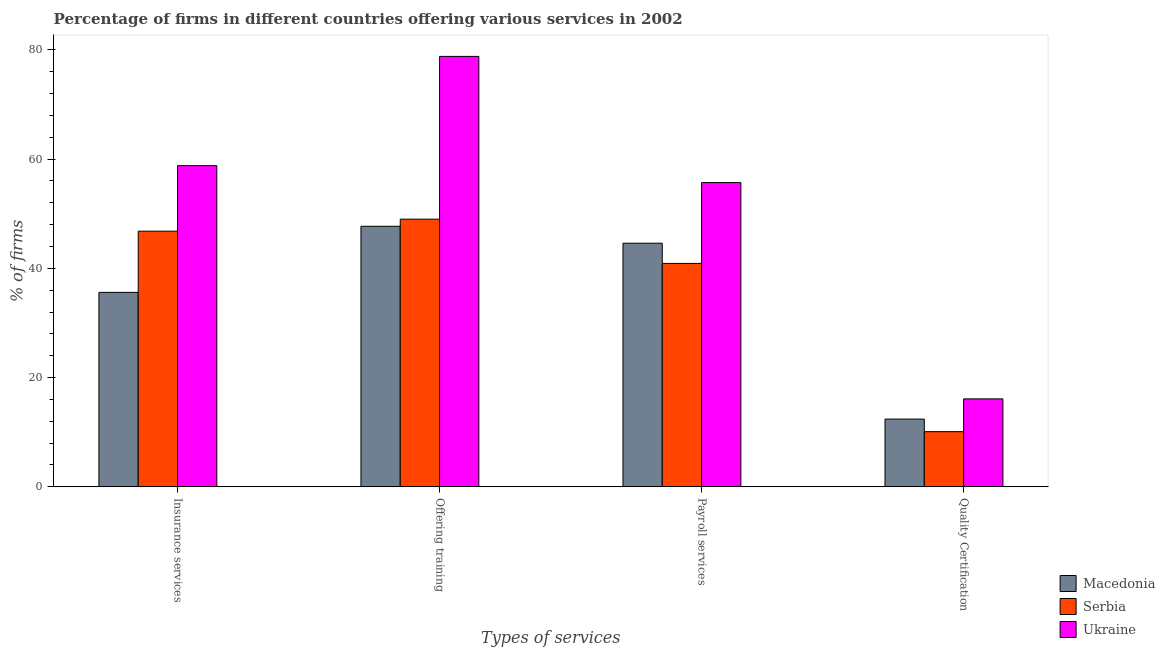How many different coloured bars are there?
Your response must be concise. 3. How many groups of bars are there?
Keep it short and to the point. 4. What is the label of the 4th group of bars from the left?
Your response must be concise. Quality Certification. What is the percentage of firms offering training in Ukraine?
Offer a terse response. 78.8. Across all countries, what is the maximum percentage of firms offering quality certification?
Provide a short and direct response. 16.1. Across all countries, what is the minimum percentage of firms offering quality certification?
Keep it short and to the point. 10.1. In which country was the percentage of firms offering quality certification maximum?
Your response must be concise. Ukraine. In which country was the percentage of firms offering payroll services minimum?
Keep it short and to the point. Serbia. What is the total percentage of firms offering training in the graph?
Provide a succinct answer. 175.5. What is the difference between the percentage of firms offering payroll services in Macedonia and that in Ukraine?
Your answer should be compact. -11.1. What is the average percentage of firms offering training per country?
Give a very brief answer. 58.5. What is the difference between the percentage of firms offering payroll services and percentage of firms offering insurance services in Serbia?
Your response must be concise. -5.9. What is the ratio of the percentage of firms offering training in Ukraine to that in Macedonia?
Give a very brief answer. 1.65. Is the difference between the percentage of firms offering training in Serbia and Ukraine greater than the difference between the percentage of firms offering quality certification in Serbia and Ukraine?
Your answer should be compact. No. What is the difference between the highest and the second highest percentage of firms offering payroll services?
Give a very brief answer. 11.1. What is the difference between the highest and the lowest percentage of firms offering quality certification?
Provide a short and direct response. 6. Is it the case that in every country, the sum of the percentage of firms offering quality certification and percentage of firms offering payroll services is greater than the sum of percentage of firms offering insurance services and percentage of firms offering training?
Your answer should be compact. Yes. What does the 1st bar from the left in Quality Certification represents?
Provide a succinct answer. Macedonia. What does the 2nd bar from the right in Offering training represents?
Ensure brevity in your answer.  Serbia. Is it the case that in every country, the sum of the percentage of firms offering insurance services and percentage of firms offering training is greater than the percentage of firms offering payroll services?
Provide a short and direct response. Yes. How many bars are there?
Provide a short and direct response. 12. Are the values on the major ticks of Y-axis written in scientific E-notation?
Provide a succinct answer. No. Does the graph contain any zero values?
Give a very brief answer. No. What is the title of the graph?
Ensure brevity in your answer.  Percentage of firms in different countries offering various services in 2002. What is the label or title of the X-axis?
Provide a short and direct response. Types of services. What is the label or title of the Y-axis?
Offer a terse response. % of firms. What is the % of firms in Macedonia in Insurance services?
Offer a terse response. 35.6. What is the % of firms of Serbia in Insurance services?
Your response must be concise. 46.8. What is the % of firms of Ukraine in Insurance services?
Keep it short and to the point. 58.8. What is the % of firms in Macedonia in Offering training?
Your response must be concise. 47.7. What is the % of firms in Serbia in Offering training?
Provide a succinct answer. 49. What is the % of firms of Ukraine in Offering training?
Make the answer very short. 78.8. What is the % of firms of Macedonia in Payroll services?
Your response must be concise. 44.6. What is the % of firms of Serbia in Payroll services?
Make the answer very short. 40.9. What is the % of firms of Ukraine in Payroll services?
Provide a short and direct response. 55.7. What is the % of firms in Serbia in Quality Certification?
Provide a succinct answer. 10.1. Across all Types of services, what is the maximum % of firms in Macedonia?
Your answer should be compact. 47.7. Across all Types of services, what is the maximum % of firms in Ukraine?
Your answer should be very brief. 78.8. Across all Types of services, what is the minimum % of firms of Serbia?
Make the answer very short. 10.1. Across all Types of services, what is the minimum % of firms in Ukraine?
Offer a very short reply. 16.1. What is the total % of firms in Macedonia in the graph?
Ensure brevity in your answer.  140.3. What is the total % of firms in Serbia in the graph?
Provide a short and direct response. 146.8. What is the total % of firms of Ukraine in the graph?
Provide a short and direct response. 209.4. What is the difference between the % of firms of Ukraine in Insurance services and that in Offering training?
Make the answer very short. -20. What is the difference between the % of firms of Ukraine in Insurance services and that in Payroll services?
Offer a terse response. 3.1. What is the difference between the % of firms of Macedonia in Insurance services and that in Quality Certification?
Provide a succinct answer. 23.2. What is the difference between the % of firms in Serbia in Insurance services and that in Quality Certification?
Your answer should be compact. 36.7. What is the difference between the % of firms of Ukraine in Insurance services and that in Quality Certification?
Your answer should be very brief. 42.7. What is the difference between the % of firms of Serbia in Offering training and that in Payroll services?
Provide a short and direct response. 8.1. What is the difference between the % of firms in Ukraine in Offering training and that in Payroll services?
Provide a succinct answer. 23.1. What is the difference between the % of firms in Macedonia in Offering training and that in Quality Certification?
Provide a succinct answer. 35.3. What is the difference between the % of firms in Serbia in Offering training and that in Quality Certification?
Keep it short and to the point. 38.9. What is the difference between the % of firms in Ukraine in Offering training and that in Quality Certification?
Keep it short and to the point. 62.7. What is the difference between the % of firms of Macedonia in Payroll services and that in Quality Certification?
Ensure brevity in your answer.  32.2. What is the difference between the % of firms in Serbia in Payroll services and that in Quality Certification?
Give a very brief answer. 30.8. What is the difference between the % of firms of Ukraine in Payroll services and that in Quality Certification?
Keep it short and to the point. 39.6. What is the difference between the % of firms in Macedonia in Insurance services and the % of firms in Ukraine in Offering training?
Your answer should be compact. -43.2. What is the difference between the % of firms in Serbia in Insurance services and the % of firms in Ukraine in Offering training?
Offer a terse response. -32. What is the difference between the % of firms of Macedonia in Insurance services and the % of firms of Ukraine in Payroll services?
Keep it short and to the point. -20.1. What is the difference between the % of firms of Macedonia in Insurance services and the % of firms of Serbia in Quality Certification?
Your response must be concise. 25.5. What is the difference between the % of firms of Macedonia in Insurance services and the % of firms of Ukraine in Quality Certification?
Keep it short and to the point. 19.5. What is the difference between the % of firms in Serbia in Insurance services and the % of firms in Ukraine in Quality Certification?
Make the answer very short. 30.7. What is the difference between the % of firms in Macedonia in Offering training and the % of firms in Serbia in Payroll services?
Provide a succinct answer. 6.8. What is the difference between the % of firms in Serbia in Offering training and the % of firms in Ukraine in Payroll services?
Offer a very short reply. -6.7. What is the difference between the % of firms of Macedonia in Offering training and the % of firms of Serbia in Quality Certification?
Provide a short and direct response. 37.6. What is the difference between the % of firms in Macedonia in Offering training and the % of firms in Ukraine in Quality Certification?
Give a very brief answer. 31.6. What is the difference between the % of firms in Serbia in Offering training and the % of firms in Ukraine in Quality Certification?
Make the answer very short. 32.9. What is the difference between the % of firms of Macedonia in Payroll services and the % of firms of Serbia in Quality Certification?
Offer a terse response. 34.5. What is the difference between the % of firms of Macedonia in Payroll services and the % of firms of Ukraine in Quality Certification?
Provide a succinct answer. 28.5. What is the difference between the % of firms in Serbia in Payroll services and the % of firms in Ukraine in Quality Certification?
Provide a short and direct response. 24.8. What is the average % of firms in Macedonia per Types of services?
Provide a succinct answer. 35.08. What is the average % of firms in Serbia per Types of services?
Provide a short and direct response. 36.7. What is the average % of firms in Ukraine per Types of services?
Your answer should be very brief. 52.35. What is the difference between the % of firms in Macedonia and % of firms in Serbia in Insurance services?
Offer a very short reply. -11.2. What is the difference between the % of firms in Macedonia and % of firms in Ukraine in Insurance services?
Offer a very short reply. -23.2. What is the difference between the % of firms of Serbia and % of firms of Ukraine in Insurance services?
Offer a very short reply. -12. What is the difference between the % of firms in Macedonia and % of firms in Ukraine in Offering training?
Make the answer very short. -31.1. What is the difference between the % of firms of Serbia and % of firms of Ukraine in Offering training?
Your response must be concise. -29.8. What is the difference between the % of firms in Serbia and % of firms in Ukraine in Payroll services?
Keep it short and to the point. -14.8. What is the difference between the % of firms in Macedonia and % of firms in Serbia in Quality Certification?
Provide a succinct answer. 2.3. What is the difference between the % of firms in Macedonia and % of firms in Ukraine in Quality Certification?
Provide a succinct answer. -3.7. What is the difference between the % of firms in Serbia and % of firms in Ukraine in Quality Certification?
Ensure brevity in your answer.  -6. What is the ratio of the % of firms in Macedonia in Insurance services to that in Offering training?
Ensure brevity in your answer.  0.75. What is the ratio of the % of firms in Serbia in Insurance services to that in Offering training?
Your response must be concise. 0.96. What is the ratio of the % of firms of Ukraine in Insurance services to that in Offering training?
Keep it short and to the point. 0.75. What is the ratio of the % of firms of Macedonia in Insurance services to that in Payroll services?
Offer a terse response. 0.8. What is the ratio of the % of firms of Serbia in Insurance services to that in Payroll services?
Ensure brevity in your answer.  1.14. What is the ratio of the % of firms of Ukraine in Insurance services to that in Payroll services?
Ensure brevity in your answer.  1.06. What is the ratio of the % of firms in Macedonia in Insurance services to that in Quality Certification?
Your answer should be compact. 2.87. What is the ratio of the % of firms of Serbia in Insurance services to that in Quality Certification?
Make the answer very short. 4.63. What is the ratio of the % of firms in Ukraine in Insurance services to that in Quality Certification?
Make the answer very short. 3.65. What is the ratio of the % of firms in Macedonia in Offering training to that in Payroll services?
Offer a terse response. 1.07. What is the ratio of the % of firms in Serbia in Offering training to that in Payroll services?
Your response must be concise. 1.2. What is the ratio of the % of firms in Ukraine in Offering training to that in Payroll services?
Ensure brevity in your answer.  1.41. What is the ratio of the % of firms in Macedonia in Offering training to that in Quality Certification?
Your response must be concise. 3.85. What is the ratio of the % of firms of Serbia in Offering training to that in Quality Certification?
Your response must be concise. 4.85. What is the ratio of the % of firms of Ukraine in Offering training to that in Quality Certification?
Your answer should be compact. 4.89. What is the ratio of the % of firms of Macedonia in Payroll services to that in Quality Certification?
Give a very brief answer. 3.6. What is the ratio of the % of firms of Serbia in Payroll services to that in Quality Certification?
Ensure brevity in your answer.  4.05. What is the ratio of the % of firms of Ukraine in Payroll services to that in Quality Certification?
Offer a terse response. 3.46. What is the difference between the highest and the second highest % of firms in Macedonia?
Keep it short and to the point. 3.1. What is the difference between the highest and the second highest % of firms in Ukraine?
Keep it short and to the point. 20. What is the difference between the highest and the lowest % of firms in Macedonia?
Ensure brevity in your answer.  35.3. What is the difference between the highest and the lowest % of firms in Serbia?
Provide a short and direct response. 38.9. What is the difference between the highest and the lowest % of firms of Ukraine?
Give a very brief answer. 62.7. 